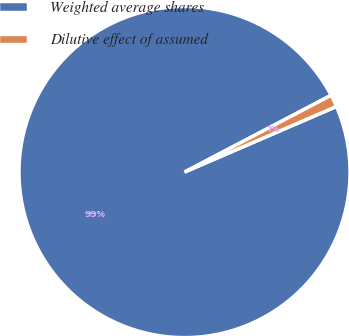Convert chart to OTSL. <chart><loc_0><loc_0><loc_500><loc_500><pie_chart><fcel>Weighted average shares<fcel>Dilutive effect of assumed<nl><fcel>98.81%<fcel>1.19%<nl></chart> 